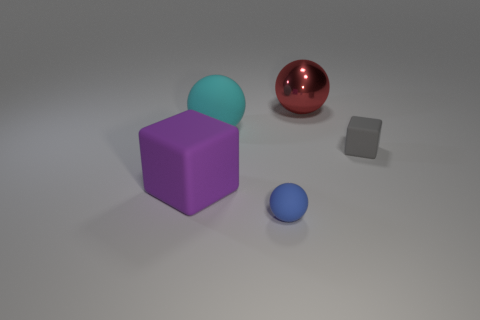Subtract all balls. How many objects are left? 2 Subtract 2 cubes. How many cubes are left? 0 Subtract all yellow balls. Subtract all brown cylinders. How many balls are left? 3 Subtract all yellow spheres. How many gray cubes are left? 1 Subtract all cyan spheres. Subtract all big red metal things. How many objects are left? 3 Add 1 small gray objects. How many small gray objects are left? 2 Add 2 tiny blue rubber spheres. How many tiny blue rubber spheres exist? 3 Add 3 large blue matte things. How many objects exist? 8 Subtract all blue spheres. How many spheres are left? 2 Subtract all blue rubber spheres. How many spheres are left? 2 